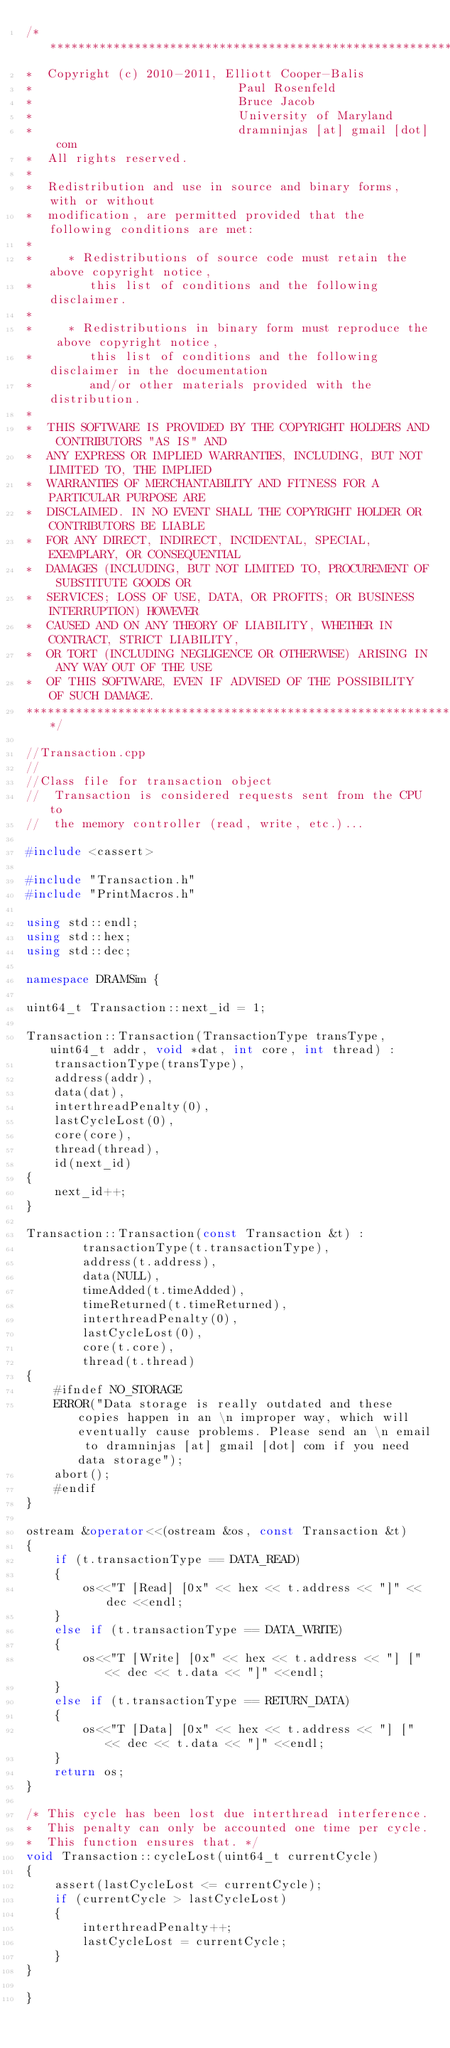Convert code to text. <code><loc_0><loc_0><loc_500><loc_500><_C++_>/*********************************************************************************
*  Copyright (c) 2010-2011, Elliott Cooper-Balis
*                             Paul Rosenfeld
*                             Bruce Jacob
*                             University of Maryland
*                             dramninjas [at] gmail [dot] com
*  All rights reserved.
*
*  Redistribution and use in source and binary forms, with or without
*  modification, are permitted provided that the following conditions are met:
*
*     * Redistributions of source code must retain the above copyright notice,
*        this list of conditions and the following disclaimer.
*
*     * Redistributions in binary form must reproduce the above copyright notice,
*        this list of conditions and the following disclaimer in the documentation
*        and/or other materials provided with the distribution.
*
*  THIS SOFTWARE IS PROVIDED BY THE COPYRIGHT HOLDERS AND CONTRIBUTORS "AS IS" AND
*  ANY EXPRESS OR IMPLIED WARRANTIES, INCLUDING, BUT NOT LIMITED TO, THE IMPLIED
*  WARRANTIES OF MERCHANTABILITY AND FITNESS FOR A PARTICULAR PURPOSE ARE
*  DISCLAIMED. IN NO EVENT SHALL THE COPYRIGHT HOLDER OR CONTRIBUTORS BE LIABLE
*  FOR ANY DIRECT, INDIRECT, INCIDENTAL, SPECIAL, EXEMPLARY, OR CONSEQUENTIAL
*  DAMAGES (INCLUDING, BUT NOT LIMITED TO, PROCUREMENT OF SUBSTITUTE GOODS OR
*  SERVICES; LOSS OF USE, DATA, OR PROFITS; OR BUSINESS INTERRUPTION) HOWEVER
*  CAUSED AND ON ANY THEORY OF LIABILITY, WHETHER IN CONTRACT, STRICT LIABILITY,
*  OR TORT (INCLUDING NEGLIGENCE OR OTHERWISE) ARISING IN ANY WAY OUT OF THE USE
*  OF THIS SOFTWARE, EVEN IF ADVISED OF THE POSSIBILITY OF SUCH DAMAGE.
*********************************************************************************/

//Transaction.cpp
//
//Class file for transaction object
//	Transaction is considered requests sent from the CPU to
//	the memory controller (read, write, etc.)...

#include <cassert>

#include "Transaction.h"
#include "PrintMacros.h"

using std::endl;
using std::hex;
using std::dec;

namespace DRAMSim {

uint64_t Transaction::next_id = 1;

Transaction::Transaction(TransactionType transType, uint64_t addr, void *dat, int core, int thread) :
	transactionType(transType),
	address(addr),
	data(dat),
	interthreadPenalty(0),
	lastCycleLost(0),
	core(core),
	thread(thread),
	id(next_id)
{
	next_id++;
}

Transaction::Transaction(const Transaction &t) :
		transactionType(t.transactionType),
		address(t.address),
		data(NULL),
		timeAdded(t.timeAdded),
		timeReturned(t.timeReturned),
		interthreadPenalty(0),
		lastCycleLost(0),
		core(t.core),
		thread(t.thread)
{
	#ifndef NO_STORAGE
	ERROR("Data storage is really outdated and these copies happen in an \n improper way, which will eventually cause problems. Please send an \n email to dramninjas [at] gmail [dot] com if you need data storage");
	abort();
	#endif
}

ostream &operator<<(ostream &os, const Transaction &t)
{
	if (t.transactionType == DATA_READ)
	{
		os<<"T [Read] [0x" << hex << t.address << "]" << dec <<endl;
	}
	else if (t.transactionType == DATA_WRITE)
	{
		os<<"T [Write] [0x" << hex << t.address << "] [" << dec << t.data << "]" <<endl;
	}
	else if (t.transactionType == RETURN_DATA)
	{
		os<<"T [Data] [0x" << hex << t.address << "] [" << dec << t.data << "]" <<endl;
	}
	return os;
}

/* This cycle has been lost due interthread interference.
*  This penalty can only be accounted one time per cycle.
*  This function ensures that. */
void Transaction::cycleLost(uint64_t currentCycle)
{
	assert(lastCycleLost <= currentCycle);
	if (currentCycle > lastCycleLost)
	{
		interthreadPenalty++;
		lastCycleLost = currentCycle;
	}
}

}

</code> 